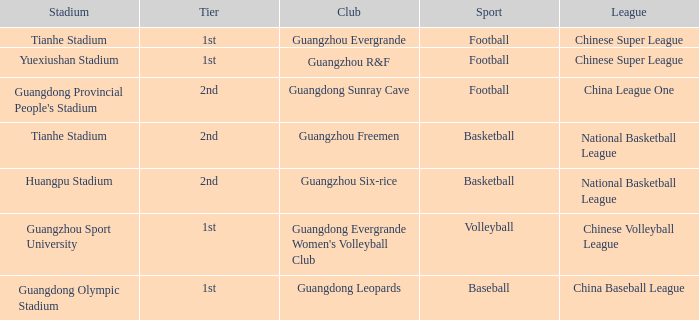Which tier is for football at Tianhe Stadium? 1st. 